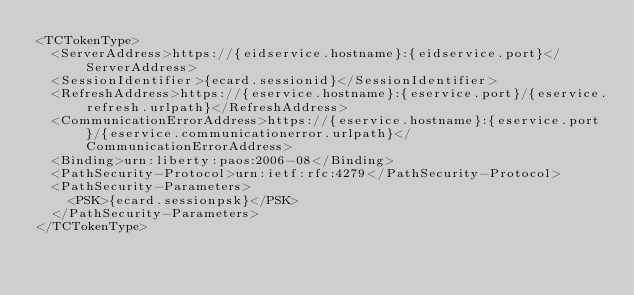Convert code to text. <code><loc_0><loc_0><loc_500><loc_500><_XML_><TCTokenType>
  <ServerAddress>https://{eidservice.hostname}:{eidservice.port}</ServerAddress>
  <SessionIdentifier>{ecard.sessionid}</SessionIdentifier>
  <RefreshAddress>https://{eservice.hostname}:{eservice.port}/{eservice.refresh.urlpath}</RefreshAddress>
  <CommunicationErrorAddress>https://{eservice.hostname}:{eservice.port}/{eservice.communicationerror.urlpath}</CommunicationErrorAddress>
  <Binding>urn:liberty:paos:2006-08</Binding>
  <PathSecurity-Protocol>urn:ietf:rfc:4279</PathSecurity-Protocol>
  <PathSecurity-Parameters>
    <PSK>{ecard.sessionpsk}</PSK>
  </PathSecurity-Parameters>
</TCTokenType>
</code> 